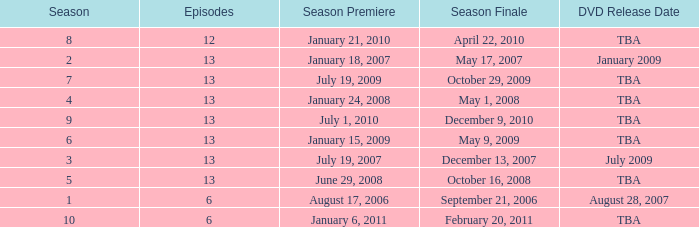Which season had fewer than 13 episodes and aired its season finale on February 20, 2011? 1.0. 